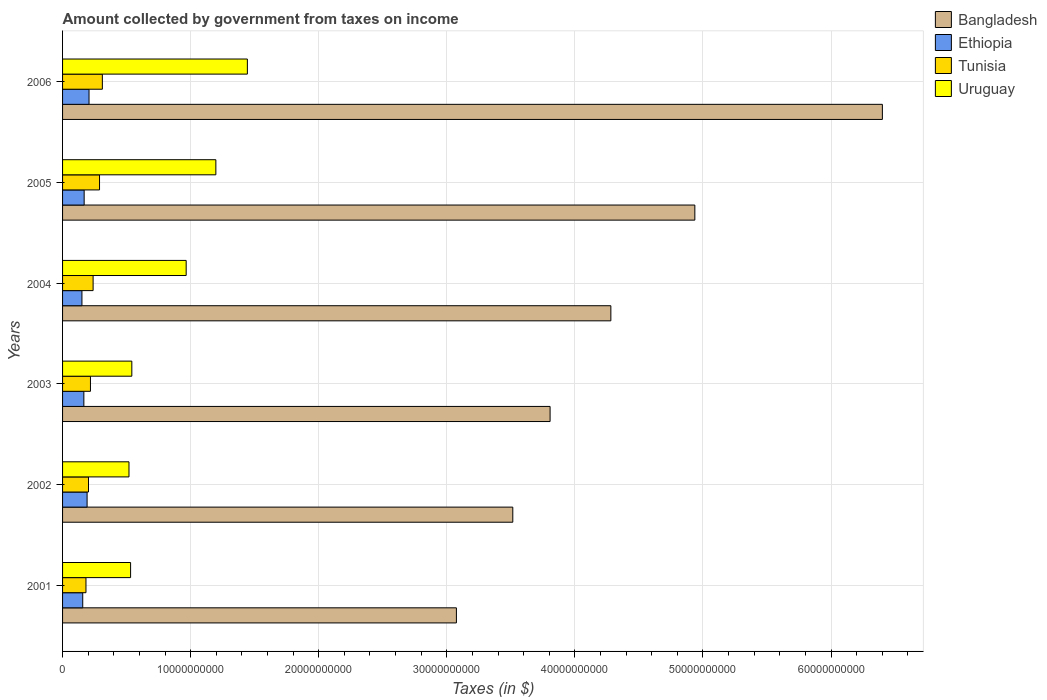How many different coloured bars are there?
Your answer should be compact. 4. Are the number of bars on each tick of the Y-axis equal?
Offer a terse response. Yes. What is the label of the 3rd group of bars from the top?
Offer a very short reply. 2004. In how many cases, is the number of bars for a given year not equal to the number of legend labels?
Offer a terse response. 0. What is the amount collected by government from taxes on income in Ethiopia in 2006?
Provide a short and direct response. 2.07e+09. Across all years, what is the maximum amount collected by government from taxes on income in Tunisia?
Provide a succinct answer. 3.11e+09. Across all years, what is the minimum amount collected by government from taxes on income in Tunisia?
Make the answer very short. 1.83e+09. What is the total amount collected by government from taxes on income in Uruguay in the graph?
Keep it short and to the point. 5.20e+1. What is the difference between the amount collected by government from taxes on income in Tunisia in 2002 and that in 2006?
Give a very brief answer. -1.08e+09. What is the difference between the amount collected by government from taxes on income in Uruguay in 2006 and the amount collected by government from taxes on income in Tunisia in 2003?
Your response must be concise. 1.23e+1. What is the average amount collected by government from taxes on income in Tunisia per year?
Provide a short and direct response. 2.40e+09. In the year 2001, what is the difference between the amount collected by government from taxes on income in Bangladesh and amount collected by government from taxes on income in Ethiopia?
Your response must be concise. 2.92e+1. In how many years, is the amount collected by government from taxes on income in Uruguay greater than 20000000000 $?
Provide a succinct answer. 0. What is the ratio of the amount collected by government from taxes on income in Tunisia in 2002 to that in 2005?
Provide a succinct answer. 0.7. Is the difference between the amount collected by government from taxes on income in Bangladesh in 2004 and 2005 greater than the difference between the amount collected by government from taxes on income in Ethiopia in 2004 and 2005?
Make the answer very short. No. What is the difference between the highest and the second highest amount collected by government from taxes on income in Tunisia?
Your answer should be very brief. 2.20e+08. What is the difference between the highest and the lowest amount collected by government from taxes on income in Uruguay?
Keep it short and to the point. 9.24e+09. What does the 1st bar from the top in 2003 represents?
Your answer should be compact. Uruguay. What does the 2nd bar from the bottom in 2001 represents?
Provide a succinct answer. Ethiopia. Is it the case that in every year, the sum of the amount collected by government from taxes on income in Bangladesh and amount collected by government from taxes on income in Ethiopia is greater than the amount collected by government from taxes on income in Tunisia?
Provide a succinct answer. Yes. Are the values on the major ticks of X-axis written in scientific E-notation?
Provide a short and direct response. No. Does the graph contain grids?
Your response must be concise. Yes. Where does the legend appear in the graph?
Keep it short and to the point. Top right. What is the title of the graph?
Provide a succinct answer. Amount collected by government from taxes on income. What is the label or title of the X-axis?
Provide a succinct answer. Taxes (in $). What is the label or title of the Y-axis?
Offer a terse response. Years. What is the Taxes (in $) in Bangladesh in 2001?
Offer a very short reply. 3.07e+1. What is the Taxes (in $) in Ethiopia in 2001?
Offer a terse response. 1.57e+09. What is the Taxes (in $) in Tunisia in 2001?
Offer a very short reply. 1.83e+09. What is the Taxes (in $) of Uruguay in 2001?
Provide a succinct answer. 5.31e+09. What is the Taxes (in $) of Bangladesh in 2002?
Give a very brief answer. 3.52e+1. What is the Taxes (in $) in Ethiopia in 2002?
Keep it short and to the point. 1.91e+09. What is the Taxes (in $) in Tunisia in 2002?
Your answer should be very brief. 2.02e+09. What is the Taxes (in $) of Uruguay in 2002?
Provide a succinct answer. 5.19e+09. What is the Taxes (in $) in Bangladesh in 2003?
Ensure brevity in your answer.  3.81e+1. What is the Taxes (in $) in Ethiopia in 2003?
Keep it short and to the point. 1.66e+09. What is the Taxes (in $) of Tunisia in 2003?
Provide a short and direct response. 2.18e+09. What is the Taxes (in $) in Uruguay in 2003?
Provide a short and direct response. 5.41e+09. What is the Taxes (in $) of Bangladesh in 2004?
Your answer should be compact. 4.28e+1. What is the Taxes (in $) of Ethiopia in 2004?
Your response must be concise. 1.51e+09. What is the Taxes (in $) in Tunisia in 2004?
Your response must be concise. 2.39e+09. What is the Taxes (in $) in Uruguay in 2004?
Give a very brief answer. 9.65e+09. What is the Taxes (in $) of Bangladesh in 2005?
Your response must be concise. 4.94e+1. What is the Taxes (in $) of Ethiopia in 2005?
Offer a terse response. 1.69e+09. What is the Taxes (in $) of Tunisia in 2005?
Provide a succinct answer. 2.89e+09. What is the Taxes (in $) of Uruguay in 2005?
Your response must be concise. 1.20e+1. What is the Taxes (in $) of Bangladesh in 2006?
Ensure brevity in your answer.  6.40e+1. What is the Taxes (in $) in Ethiopia in 2006?
Ensure brevity in your answer.  2.07e+09. What is the Taxes (in $) in Tunisia in 2006?
Your answer should be compact. 3.11e+09. What is the Taxes (in $) of Uruguay in 2006?
Your response must be concise. 1.44e+1. Across all years, what is the maximum Taxes (in $) in Bangladesh?
Keep it short and to the point. 6.40e+1. Across all years, what is the maximum Taxes (in $) in Ethiopia?
Make the answer very short. 2.07e+09. Across all years, what is the maximum Taxes (in $) in Tunisia?
Keep it short and to the point. 3.11e+09. Across all years, what is the maximum Taxes (in $) in Uruguay?
Offer a very short reply. 1.44e+1. Across all years, what is the minimum Taxes (in $) of Bangladesh?
Provide a short and direct response. 3.07e+1. Across all years, what is the minimum Taxes (in $) in Ethiopia?
Make the answer very short. 1.51e+09. Across all years, what is the minimum Taxes (in $) in Tunisia?
Offer a terse response. 1.83e+09. Across all years, what is the minimum Taxes (in $) of Uruguay?
Your answer should be compact. 5.19e+09. What is the total Taxes (in $) of Bangladesh in the graph?
Make the answer very short. 2.60e+11. What is the total Taxes (in $) in Ethiopia in the graph?
Make the answer very short. 1.04e+1. What is the total Taxes (in $) of Tunisia in the graph?
Your answer should be very brief. 1.44e+1. What is the total Taxes (in $) of Uruguay in the graph?
Make the answer very short. 5.20e+1. What is the difference between the Taxes (in $) of Bangladesh in 2001 and that in 2002?
Your answer should be very brief. -4.40e+09. What is the difference between the Taxes (in $) of Ethiopia in 2001 and that in 2002?
Your response must be concise. -3.40e+08. What is the difference between the Taxes (in $) in Tunisia in 2001 and that in 2002?
Your answer should be very brief. -1.97e+08. What is the difference between the Taxes (in $) of Uruguay in 2001 and that in 2002?
Offer a very short reply. 1.25e+08. What is the difference between the Taxes (in $) of Bangladesh in 2001 and that in 2003?
Provide a succinct answer. -7.31e+09. What is the difference between the Taxes (in $) of Ethiopia in 2001 and that in 2003?
Offer a very short reply. -8.84e+07. What is the difference between the Taxes (in $) of Tunisia in 2001 and that in 2003?
Give a very brief answer. -3.49e+08. What is the difference between the Taxes (in $) in Uruguay in 2001 and that in 2003?
Your answer should be very brief. -9.64e+07. What is the difference between the Taxes (in $) in Bangladesh in 2001 and that in 2004?
Offer a terse response. -1.21e+1. What is the difference between the Taxes (in $) of Ethiopia in 2001 and that in 2004?
Provide a succinct answer. 6.19e+07. What is the difference between the Taxes (in $) in Tunisia in 2001 and that in 2004?
Make the answer very short. -5.58e+08. What is the difference between the Taxes (in $) of Uruguay in 2001 and that in 2004?
Your answer should be compact. -4.34e+09. What is the difference between the Taxes (in $) in Bangladesh in 2001 and that in 2005?
Provide a short and direct response. -1.86e+1. What is the difference between the Taxes (in $) in Ethiopia in 2001 and that in 2005?
Ensure brevity in your answer.  -1.11e+08. What is the difference between the Taxes (in $) in Tunisia in 2001 and that in 2005?
Ensure brevity in your answer.  -1.06e+09. What is the difference between the Taxes (in $) in Uruguay in 2001 and that in 2005?
Your answer should be compact. -6.66e+09. What is the difference between the Taxes (in $) in Bangladesh in 2001 and that in 2006?
Ensure brevity in your answer.  -3.33e+1. What is the difference between the Taxes (in $) in Ethiopia in 2001 and that in 2006?
Offer a terse response. -4.92e+08. What is the difference between the Taxes (in $) in Tunisia in 2001 and that in 2006?
Make the answer very short. -1.28e+09. What is the difference between the Taxes (in $) in Uruguay in 2001 and that in 2006?
Offer a very short reply. -9.12e+09. What is the difference between the Taxes (in $) of Bangladesh in 2002 and that in 2003?
Provide a short and direct response. -2.91e+09. What is the difference between the Taxes (in $) in Ethiopia in 2002 and that in 2003?
Your answer should be compact. 2.52e+08. What is the difference between the Taxes (in $) of Tunisia in 2002 and that in 2003?
Make the answer very short. -1.53e+08. What is the difference between the Taxes (in $) in Uruguay in 2002 and that in 2003?
Give a very brief answer. -2.22e+08. What is the difference between the Taxes (in $) of Bangladesh in 2002 and that in 2004?
Provide a short and direct response. -7.66e+09. What is the difference between the Taxes (in $) in Ethiopia in 2002 and that in 2004?
Offer a terse response. 4.02e+08. What is the difference between the Taxes (in $) in Tunisia in 2002 and that in 2004?
Give a very brief answer. -3.61e+08. What is the difference between the Taxes (in $) of Uruguay in 2002 and that in 2004?
Provide a short and direct response. -4.46e+09. What is the difference between the Taxes (in $) of Bangladesh in 2002 and that in 2005?
Your answer should be very brief. -1.42e+1. What is the difference between the Taxes (in $) in Ethiopia in 2002 and that in 2005?
Your answer should be very brief. 2.29e+08. What is the difference between the Taxes (in $) in Tunisia in 2002 and that in 2005?
Offer a very short reply. -8.62e+08. What is the difference between the Taxes (in $) of Uruguay in 2002 and that in 2005?
Your answer should be compact. -6.78e+09. What is the difference between the Taxes (in $) of Bangladesh in 2002 and that in 2006?
Your response must be concise. -2.89e+1. What is the difference between the Taxes (in $) in Ethiopia in 2002 and that in 2006?
Give a very brief answer. -1.51e+08. What is the difference between the Taxes (in $) in Tunisia in 2002 and that in 2006?
Provide a succinct answer. -1.08e+09. What is the difference between the Taxes (in $) in Uruguay in 2002 and that in 2006?
Give a very brief answer. -9.24e+09. What is the difference between the Taxes (in $) of Bangladesh in 2003 and that in 2004?
Your response must be concise. -4.74e+09. What is the difference between the Taxes (in $) in Ethiopia in 2003 and that in 2004?
Provide a succinct answer. 1.50e+08. What is the difference between the Taxes (in $) of Tunisia in 2003 and that in 2004?
Keep it short and to the point. -2.08e+08. What is the difference between the Taxes (in $) of Uruguay in 2003 and that in 2004?
Offer a terse response. -4.24e+09. What is the difference between the Taxes (in $) in Bangladesh in 2003 and that in 2005?
Offer a terse response. -1.13e+1. What is the difference between the Taxes (in $) of Ethiopia in 2003 and that in 2005?
Your response must be concise. -2.28e+07. What is the difference between the Taxes (in $) of Tunisia in 2003 and that in 2005?
Offer a terse response. -7.09e+08. What is the difference between the Taxes (in $) in Uruguay in 2003 and that in 2005?
Make the answer very short. -6.56e+09. What is the difference between the Taxes (in $) of Bangladesh in 2003 and that in 2006?
Ensure brevity in your answer.  -2.59e+1. What is the difference between the Taxes (in $) in Ethiopia in 2003 and that in 2006?
Your answer should be very brief. -4.03e+08. What is the difference between the Taxes (in $) of Tunisia in 2003 and that in 2006?
Keep it short and to the point. -9.30e+08. What is the difference between the Taxes (in $) of Uruguay in 2003 and that in 2006?
Offer a very short reply. -9.02e+09. What is the difference between the Taxes (in $) of Bangladesh in 2004 and that in 2005?
Your answer should be compact. -6.56e+09. What is the difference between the Taxes (in $) in Ethiopia in 2004 and that in 2005?
Your answer should be compact. -1.73e+08. What is the difference between the Taxes (in $) of Tunisia in 2004 and that in 2005?
Give a very brief answer. -5.01e+08. What is the difference between the Taxes (in $) in Uruguay in 2004 and that in 2005?
Provide a succinct answer. -2.32e+09. What is the difference between the Taxes (in $) of Bangladesh in 2004 and that in 2006?
Give a very brief answer. -2.12e+1. What is the difference between the Taxes (in $) in Ethiopia in 2004 and that in 2006?
Give a very brief answer. -5.54e+08. What is the difference between the Taxes (in $) in Tunisia in 2004 and that in 2006?
Give a very brief answer. -7.22e+08. What is the difference between the Taxes (in $) of Uruguay in 2004 and that in 2006?
Ensure brevity in your answer.  -4.78e+09. What is the difference between the Taxes (in $) of Bangladesh in 2005 and that in 2006?
Your answer should be very brief. -1.46e+1. What is the difference between the Taxes (in $) of Ethiopia in 2005 and that in 2006?
Make the answer very short. -3.80e+08. What is the difference between the Taxes (in $) in Tunisia in 2005 and that in 2006?
Ensure brevity in your answer.  -2.20e+08. What is the difference between the Taxes (in $) of Uruguay in 2005 and that in 2006?
Your answer should be very brief. -2.46e+09. What is the difference between the Taxes (in $) of Bangladesh in 2001 and the Taxes (in $) of Ethiopia in 2002?
Your response must be concise. 2.88e+1. What is the difference between the Taxes (in $) in Bangladesh in 2001 and the Taxes (in $) in Tunisia in 2002?
Offer a terse response. 2.87e+1. What is the difference between the Taxes (in $) in Bangladesh in 2001 and the Taxes (in $) in Uruguay in 2002?
Your response must be concise. 2.56e+1. What is the difference between the Taxes (in $) of Ethiopia in 2001 and the Taxes (in $) of Tunisia in 2002?
Your answer should be compact. -4.50e+08. What is the difference between the Taxes (in $) of Ethiopia in 2001 and the Taxes (in $) of Uruguay in 2002?
Provide a succinct answer. -3.61e+09. What is the difference between the Taxes (in $) in Tunisia in 2001 and the Taxes (in $) in Uruguay in 2002?
Keep it short and to the point. -3.36e+09. What is the difference between the Taxes (in $) of Bangladesh in 2001 and the Taxes (in $) of Ethiopia in 2003?
Your response must be concise. 2.91e+1. What is the difference between the Taxes (in $) of Bangladesh in 2001 and the Taxes (in $) of Tunisia in 2003?
Keep it short and to the point. 2.86e+1. What is the difference between the Taxes (in $) of Bangladesh in 2001 and the Taxes (in $) of Uruguay in 2003?
Your answer should be compact. 2.53e+1. What is the difference between the Taxes (in $) in Ethiopia in 2001 and the Taxes (in $) in Tunisia in 2003?
Provide a short and direct response. -6.02e+08. What is the difference between the Taxes (in $) in Ethiopia in 2001 and the Taxes (in $) in Uruguay in 2003?
Offer a very short reply. -3.83e+09. What is the difference between the Taxes (in $) of Tunisia in 2001 and the Taxes (in $) of Uruguay in 2003?
Provide a short and direct response. -3.58e+09. What is the difference between the Taxes (in $) in Bangladesh in 2001 and the Taxes (in $) in Ethiopia in 2004?
Provide a succinct answer. 2.92e+1. What is the difference between the Taxes (in $) of Bangladesh in 2001 and the Taxes (in $) of Tunisia in 2004?
Give a very brief answer. 2.84e+1. What is the difference between the Taxes (in $) of Bangladesh in 2001 and the Taxes (in $) of Uruguay in 2004?
Offer a very short reply. 2.11e+1. What is the difference between the Taxes (in $) of Ethiopia in 2001 and the Taxes (in $) of Tunisia in 2004?
Make the answer very short. -8.11e+08. What is the difference between the Taxes (in $) of Ethiopia in 2001 and the Taxes (in $) of Uruguay in 2004?
Provide a succinct answer. -8.08e+09. What is the difference between the Taxes (in $) of Tunisia in 2001 and the Taxes (in $) of Uruguay in 2004?
Keep it short and to the point. -7.82e+09. What is the difference between the Taxes (in $) in Bangladesh in 2001 and the Taxes (in $) in Ethiopia in 2005?
Provide a short and direct response. 2.91e+1. What is the difference between the Taxes (in $) in Bangladesh in 2001 and the Taxes (in $) in Tunisia in 2005?
Your answer should be very brief. 2.79e+1. What is the difference between the Taxes (in $) in Bangladesh in 2001 and the Taxes (in $) in Uruguay in 2005?
Provide a short and direct response. 1.88e+1. What is the difference between the Taxes (in $) of Ethiopia in 2001 and the Taxes (in $) of Tunisia in 2005?
Your answer should be very brief. -1.31e+09. What is the difference between the Taxes (in $) of Ethiopia in 2001 and the Taxes (in $) of Uruguay in 2005?
Keep it short and to the point. -1.04e+1. What is the difference between the Taxes (in $) in Tunisia in 2001 and the Taxes (in $) in Uruguay in 2005?
Provide a short and direct response. -1.01e+1. What is the difference between the Taxes (in $) in Bangladesh in 2001 and the Taxes (in $) in Ethiopia in 2006?
Your answer should be very brief. 2.87e+1. What is the difference between the Taxes (in $) of Bangladesh in 2001 and the Taxes (in $) of Tunisia in 2006?
Ensure brevity in your answer.  2.76e+1. What is the difference between the Taxes (in $) in Bangladesh in 2001 and the Taxes (in $) in Uruguay in 2006?
Provide a succinct answer. 1.63e+1. What is the difference between the Taxes (in $) in Ethiopia in 2001 and the Taxes (in $) in Tunisia in 2006?
Keep it short and to the point. -1.53e+09. What is the difference between the Taxes (in $) of Ethiopia in 2001 and the Taxes (in $) of Uruguay in 2006?
Your response must be concise. -1.29e+1. What is the difference between the Taxes (in $) in Tunisia in 2001 and the Taxes (in $) in Uruguay in 2006?
Make the answer very short. -1.26e+1. What is the difference between the Taxes (in $) in Bangladesh in 2002 and the Taxes (in $) in Ethiopia in 2003?
Provide a short and direct response. 3.35e+1. What is the difference between the Taxes (in $) of Bangladesh in 2002 and the Taxes (in $) of Tunisia in 2003?
Ensure brevity in your answer.  3.30e+1. What is the difference between the Taxes (in $) in Bangladesh in 2002 and the Taxes (in $) in Uruguay in 2003?
Keep it short and to the point. 2.97e+1. What is the difference between the Taxes (in $) of Ethiopia in 2002 and the Taxes (in $) of Tunisia in 2003?
Make the answer very short. -2.62e+08. What is the difference between the Taxes (in $) of Ethiopia in 2002 and the Taxes (in $) of Uruguay in 2003?
Your answer should be very brief. -3.49e+09. What is the difference between the Taxes (in $) in Tunisia in 2002 and the Taxes (in $) in Uruguay in 2003?
Offer a very short reply. -3.38e+09. What is the difference between the Taxes (in $) of Bangladesh in 2002 and the Taxes (in $) of Ethiopia in 2004?
Provide a succinct answer. 3.36e+1. What is the difference between the Taxes (in $) of Bangladesh in 2002 and the Taxes (in $) of Tunisia in 2004?
Your answer should be very brief. 3.28e+1. What is the difference between the Taxes (in $) in Bangladesh in 2002 and the Taxes (in $) in Uruguay in 2004?
Ensure brevity in your answer.  2.55e+1. What is the difference between the Taxes (in $) in Ethiopia in 2002 and the Taxes (in $) in Tunisia in 2004?
Ensure brevity in your answer.  -4.71e+08. What is the difference between the Taxes (in $) in Ethiopia in 2002 and the Taxes (in $) in Uruguay in 2004?
Keep it short and to the point. -7.74e+09. What is the difference between the Taxes (in $) of Tunisia in 2002 and the Taxes (in $) of Uruguay in 2004?
Your answer should be compact. -7.63e+09. What is the difference between the Taxes (in $) in Bangladesh in 2002 and the Taxes (in $) in Ethiopia in 2005?
Ensure brevity in your answer.  3.35e+1. What is the difference between the Taxes (in $) of Bangladesh in 2002 and the Taxes (in $) of Tunisia in 2005?
Your answer should be very brief. 3.23e+1. What is the difference between the Taxes (in $) in Bangladesh in 2002 and the Taxes (in $) in Uruguay in 2005?
Offer a terse response. 2.32e+1. What is the difference between the Taxes (in $) of Ethiopia in 2002 and the Taxes (in $) of Tunisia in 2005?
Your response must be concise. -9.72e+08. What is the difference between the Taxes (in $) of Ethiopia in 2002 and the Taxes (in $) of Uruguay in 2005?
Provide a succinct answer. -1.01e+1. What is the difference between the Taxes (in $) in Tunisia in 2002 and the Taxes (in $) in Uruguay in 2005?
Offer a very short reply. -9.94e+09. What is the difference between the Taxes (in $) of Bangladesh in 2002 and the Taxes (in $) of Ethiopia in 2006?
Make the answer very short. 3.31e+1. What is the difference between the Taxes (in $) in Bangladesh in 2002 and the Taxes (in $) in Tunisia in 2006?
Ensure brevity in your answer.  3.20e+1. What is the difference between the Taxes (in $) in Bangladesh in 2002 and the Taxes (in $) in Uruguay in 2006?
Your answer should be compact. 2.07e+1. What is the difference between the Taxes (in $) in Ethiopia in 2002 and the Taxes (in $) in Tunisia in 2006?
Offer a terse response. -1.19e+09. What is the difference between the Taxes (in $) of Ethiopia in 2002 and the Taxes (in $) of Uruguay in 2006?
Your answer should be very brief. -1.25e+1. What is the difference between the Taxes (in $) in Tunisia in 2002 and the Taxes (in $) in Uruguay in 2006?
Give a very brief answer. -1.24e+1. What is the difference between the Taxes (in $) in Bangladesh in 2003 and the Taxes (in $) in Ethiopia in 2004?
Make the answer very short. 3.66e+1. What is the difference between the Taxes (in $) in Bangladesh in 2003 and the Taxes (in $) in Tunisia in 2004?
Keep it short and to the point. 3.57e+1. What is the difference between the Taxes (in $) of Bangladesh in 2003 and the Taxes (in $) of Uruguay in 2004?
Your answer should be compact. 2.84e+1. What is the difference between the Taxes (in $) in Ethiopia in 2003 and the Taxes (in $) in Tunisia in 2004?
Make the answer very short. -7.22e+08. What is the difference between the Taxes (in $) in Ethiopia in 2003 and the Taxes (in $) in Uruguay in 2004?
Provide a short and direct response. -7.99e+09. What is the difference between the Taxes (in $) of Tunisia in 2003 and the Taxes (in $) of Uruguay in 2004?
Provide a short and direct response. -7.47e+09. What is the difference between the Taxes (in $) of Bangladesh in 2003 and the Taxes (in $) of Ethiopia in 2005?
Give a very brief answer. 3.64e+1. What is the difference between the Taxes (in $) of Bangladesh in 2003 and the Taxes (in $) of Tunisia in 2005?
Your answer should be compact. 3.52e+1. What is the difference between the Taxes (in $) in Bangladesh in 2003 and the Taxes (in $) in Uruguay in 2005?
Give a very brief answer. 2.61e+1. What is the difference between the Taxes (in $) in Ethiopia in 2003 and the Taxes (in $) in Tunisia in 2005?
Provide a short and direct response. -1.22e+09. What is the difference between the Taxes (in $) of Ethiopia in 2003 and the Taxes (in $) of Uruguay in 2005?
Your response must be concise. -1.03e+1. What is the difference between the Taxes (in $) of Tunisia in 2003 and the Taxes (in $) of Uruguay in 2005?
Provide a short and direct response. -9.79e+09. What is the difference between the Taxes (in $) of Bangladesh in 2003 and the Taxes (in $) of Ethiopia in 2006?
Your response must be concise. 3.60e+1. What is the difference between the Taxes (in $) in Bangladesh in 2003 and the Taxes (in $) in Tunisia in 2006?
Offer a terse response. 3.50e+1. What is the difference between the Taxes (in $) in Bangladesh in 2003 and the Taxes (in $) in Uruguay in 2006?
Your answer should be compact. 2.36e+1. What is the difference between the Taxes (in $) in Ethiopia in 2003 and the Taxes (in $) in Tunisia in 2006?
Provide a succinct answer. -1.44e+09. What is the difference between the Taxes (in $) in Ethiopia in 2003 and the Taxes (in $) in Uruguay in 2006?
Ensure brevity in your answer.  -1.28e+1. What is the difference between the Taxes (in $) in Tunisia in 2003 and the Taxes (in $) in Uruguay in 2006?
Your answer should be very brief. -1.23e+1. What is the difference between the Taxes (in $) of Bangladesh in 2004 and the Taxes (in $) of Ethiopia in 2005?
Offer a very short reply. 4.11e+1. What is the difference between the Taxes (in $) of Bangladesh in 2004 and the Taxes (in $) of Tunisia in 2005?
Offer a very short reply. 3.99e+1. What is the difference between the Taxes (in $) of Bangladesh in 2004 and the Taxes (in $) of Uruguay in 2005?
Provide a succinct answer. 3.08e+1. What is the difference between the Taxes (in $) of Ethiopia in 2004 and the Taxes (in $) of Tunisia in 2005?
Keep it short and to the point. -1.37e+09. What is the difference between the Taxes (in $) of Ethiopia in 2004 and the Taxes (in $) of Uruguay in 2005?
Offer a very short reply. -1.05e+1. What is the difference between the Taxes (in $) in Tunisia in 2004 and the Taxes (in $) in Uruguay in 2005?
Your response must be concise. -9.58e+09. What is the difference between the Taxes (in $) of Bangladesh in 2004 and the Taxes (in $) of Ethiopia in 2006?
Give a very brief answer. 4.07e+1. What is the difference between the Taxes (in $) in Bangladesh in 2004 and the Taxes (in $) in Tunisia in 2006?
Provide a succinct answer. 3.97e+1. What is the difference between the Taxes (in $) in Bangladesh in 2004 and the Taxes (in $) in Uruguay in 2006?
Your answer should be very brief. 2.84e+1. What is the difference between the Taxes (in $) of Ethiopia in 2004 and the Taxes (in $) of Tunisia in 2006?
Give a very brief answer. -1.59e+09. What is the difference between the Taxes (in $) in Ethiopia in 2004 and the Taxes (in $) in Uruguay in 2006?
Keep it short and to the point. -1.29e+1. What is the difference between the Taxes (in $) in Tunisia in 2004 and the Taxes (in $) in Uruguay in 2006?
Your answer should be compact. -1.20e+1. What is the difference between the Taxes (in $) of Bangladesh in 2005 and the Taxes (in $) of Ethiopia in 2006?
Offer a terse response. 4.73e+1. What is the difference between the Taxes (in $) of Bangladesh in 2005 and the Taxes (in $) of Tunisia in 2006?
Ensure brevity in your answer.  4.63e+1. What is the difference between the Taxes (in $) of Bangladesh in 2005 and the Taxes (in $) of Uruguay in 2006?
Offer a very short reply. 3.49e+1. What is the difference between the Taxes (in $) of Ethiopia in 2005 and the Taxes (in $) of Tunisia in 2006?
Offer a very short reply. -1.42e+09. What is the difference between the Taxes (in $) in Ethiopia in 2005 and the Taxes (in $) in Uruguay in 2006?
Make the answer very short. -1.27e+1. What is the difference between the Taxes (in $) in Tunisia in 2005 and the Taxes (in $) in Uruguay in 2006?
Provide a succinct answer. -1.15e+1. What is the average Taxes (in $) of Bangladesh per year?
Offer a terse response. 4.34e+1. What is the average Taxes (in $) in Ethiopia per year?
Give a very brief answer. 1.74e+09. What is the average Taxes (in $) in Tunisia per year?
Offer a very short reply. 2.40e+09. What is the average Taxes (in $) in Uruguay per year?
Offer a terse response. 8.66e+09. In the year 2001, what is the difference between the Taxes (in $) of Bangladesh and Taxes (in $) of Ethiopia?
Offer a terse response. 2.92e+1. In the year 2001, what is the difference between the Taxes (in $) in Bangladesh and Taxes (in $) in Tunisia?
Your response must be concise. 2.89e+1. In the year 2001, what is the difference between the Taxes (in $) of Bangladesh and Taxes (in $) of Uruguay?
Offer a terse response. 2.54e+1. In the year 2001, what is the difference between the Taxes (in $) in Ethiopia and Taxes (in $) in Tunisia?
Keep it short and to the point. -2.53e+08. In the year 2001, what is the difference between the Taxes (in $) in Ethiopia and Taxes (in $) in Uruguay?
Provide a succinct answer. -3.74e+09. In the year 2001, what is the difference between the Taxes (in $) in Tunisia and Taxes (in $) in Uruguay?
Provide a short and direct response. -3.48e+09. In the year 2002, what is the difference between the Taxes (in $) in Bangladesh and Taxes (in $) in Ethiopia?
Provide a succinct answer. 3.32e+1. In the year 2002, what is the difference between the Taxes (in $) in Bangladesh and Taxes (in $) in Tunisia?
Your response must be concise. 3.31e+1. In the year 2002, what is the difference between the Taxes (in $) in Bangladesh and Taxes (in $) in Uruguay?
Your answer should be very brief. 3.00e+1. In the year 2002, what is the difference between the Taxes (in $) of Ethiopia and Taxes (in $) of Tunisia?
Your answer should be very brief. -1.10e+08. In the year 2002, what is the difference between the Taxes (in $) in Ethiopia and Taxes (in $) in Uruguay?
Your answer should be compact. -3.27e+09. In the year 2002, what is the difference between the Taxes (in $) in Tunisia and Taxes (in $) in Uruguay?
Keep it short and to the point. -3.16e+09. In the year 2003, what is the difference between the Taxes (in $) of Bangladesh and Taxes (in $) of Ethiopia?
Your answer should be compact. 3.64e+1. In the year 2003, what is the difference between the Taxes (in $) in Bangladesh and Taxes (in $) in Tunisia?
Make the answer very short. 3.59e+1. In the year 2003, what is the difference between the Taxes (in $) of Bangladesh and Taxes (in $) of Uruguay?
Your answer should be very brief. 3.27e+1. In the year 2003, what is the difference between the Taxes (in $) in Ethiopia and Taxes (in $) in Tunisia?
Your answer should be compact. -5.14e+08. In the year 2003, what is the difference between the Taxes (in $) in Ethiopia and Taxes (in $) in Uruguay?
Give a very brief answer. -3.74e+09. In the year 2003, what is the difference between the Taxes (in $) of Tunisia and Taxes (in $) of Uruguay?
Offer a very short reply. -3.23e+09. In the year 2004, what is the difference between the Taxes (in $) of Bangladesh and Taxes (in $) of Ethiopia?
Offer a very short reply. 4.13e+1. In the year 2004, what is the difference between the Taxes (in $) in Bangladesh and Taxes (in $) in Tunisia?
Your answer should be compact. 4.04e+1. In the year 2004, what is the difference between the Taxes (in $) in Bangladesh and Taxes (in $) in Uruguay?
Keep it short and to the point. 3.32e+1. In the year 2004, what is the difference between the Taxes (in $) of Ethiopia and Taxes (in $) of Tunisia?
Your answer should be very brief. -8.73e+08. In the year 2004, what is the difference between the Taxes (in $) in Ethiopia and Taxes (in $) in Uruguay?
Give a very brief answer. -8.14e+09. In the year 2004, what is the difference between the Taxes (in $) of Tunisia and Taxes (in $) of Uruguay?
Provide a succinct answer. -7.27e+09. In the year 2005, what is the difference between the Taxes (in $) in Bangladesh and Taxes (in $) in Ethiopia?
Keep it short and to the point. 4.77e+1. In the year 2005, what is the difference between the Taxes (in $) of Bangladesh and Taxes (in $) of Tunisia?
Ensure brevity in your answer.  4.65e+1. In the year 2005, what is the difference between the Taxes (in $) of Bangladesh and Taxes (in $) of Uruguay?
Your response must be concise. 3.74e+1. In the year 2005, what is the difference between the Taxes (in $) of Ethiopia and Taxes (in $) of Tunisia?
Your response must be concise. -1.20e+09. In the year 2005, what is the difference between the Taxes (in $) of Ethiopia and Taxes (in $) of Uruguay?
Your response must be concise. -1.03e+1. In the year 2005, what is the difference between the Taxes (in $) of Tunisia and Taxes (in $) of Uruguay?
Keep it short and to the point. -9.08e+09. In the year 2006, what is the difference between the Taxes (in $) of Bangladesh and Taxes (in $) of Ethiopia?
Your response must be concise. 6.19e+1. In the year 2006, what is the difference between the Taxes (in $) of Bangladesh and Taxes (in $) of Tunisia?
Offer a very short reply. 6.09e+1. In the year 2006, what is the difference between the Taxes (in $) in Bangladesh and Taxes (in $) in Uruguay?
Ensure brevity in your answer.  4.96e+1. In the year 2006, what is the difference between the Taxes (in $) in Ethiopia and Taxes (in $) in Tunisia?
Provide a short and direct response. -1.04e+09. In the year 2006, what is the difference between the Taxes (in $) of Ethiopia and Taxes (in $) of Uruguay?
Give a very brief answer. -1.24e+1. In the year 2006, what is the difference between the Taxes (in $) in Tunisia and Taxes (in $) in Uruguay?
Offer a very short reply. -1.13e+1. What is the ratio of the Taxes (in $) of Bangladesh in 2001 to that in 2002?
Keep it short and to the point. 0.87. What is the ratio of the Taxes (in $) of Ethiopia in 2001 to that in 2002?
Offer a terse response. 0.82. What is the ratio of the Taxes (in $) of Tunisia in 2001 to that in 2002?
Provide a succinct answer. 0.9. What is the ratio of the Taxes (in $) of Uruguay in 2001 to that in 2002?
Offer a terse response. 1.02. What is the ratio of the Taxes (in $) of Bangladesh in 2001 to that in 2003?
Provide a short and direct response. 0.81. What is the ratio of the Taxes (in $) of Ethiopia in 2001 to that in 2003?
Provide a succinct answer. 0.95. What is the ratio of the Taxes (in $) in Tunisia in 2001 to that in 2003?
Your answer should be very brief. 0.84. What is the ratio of the Taxes (in $) in Uruguay in 2001 to that in 2003?
Your answer should be compact. 0.98. What is the ratio of the Taxes (in $) in Bangladesh in 2001 to that in 2004?
Provide a short and direct response. 0.72. What is the ratio of the Taxes (in $) in Ethiopia in 2001 to that in 2004?
Give a very brief answer. 1.04. What is the ratio of the Taxes (in $) of Tunisia in 2001 to that in 2004?
Keep it short and to the point. 0.77. What is the ratio of the Taxes (in $) in Uruguay in 2001 to that in 2004?
Keep it short and to the point. 0.55. What is the ratio of the Taxes (in $) of Bangladesh in 2001 to that in 2005?
Give a very brief answer. 0.62. What is the ratio of the Taxes (in $) in Ethiopia in 2001 to that in 2005?
Your response must be concise. 0.93. What is the ratio of the Taxes (in $) of Tunisia in 2001 to that in 2005?
Offer a very short reply. 0.63. What is the ratio of the Taxes (in $) of Uruguay in 2001 to that in 2005?
Your answer should be very brief. 0.44. What is the ratio of the Taxes (in $) in Bangladesh in 2001 to that in 2006?
Provide a short and direct response. 0.48. What is the ratio of the Taxes (in $) of Ethiopia in 2001 to that in 2006?
Make the answer very short. 0.76. What is the ratio of the Taxes (in $) in Tunisia in 2001 to that in 2006?
Provide a succinct answer. 0.59. What is the ratio of the Taxes (in $) of Uruguay in 2001 to that in 2006?
Your answer should be very brief. 0.37. What is the ratio of the Taxes (in $) in Bangladesh in 2002 to that in 2003?
Provide a short and direct response. 0.92. What is the ratio of the Taxes (in $) of Ethiopia in 2002 to that in 2003?
Give a very brief answer. 1.15. What is the ratio of the Taxes (in $) of Tunisia in 2002 to that in 2003?
Your answer should be compact. 0.93. What is the ratio of the Taxes (in $) in Bangladesh in 2002 to that in 2004?
Provide a short and direct response. 0.82. What is the ratio of the Taxes (in $) in Ethiopia in 2002 to that in 2004?
Keep it short and to the point. 1.27. What is the ratio of the Taxes (in $) in Tunisia in 2002 to that in 2004?
Offer a very short reply. 0.85. What is the ratio of the Taxes (in $) in Uruguay in 2002 to that in 2004?
Your answer should be compact. 0.54. What is the ratio of the Taxes (in $) of Bangladesh in 2002 to that in 2005?
Provide a short and direct response. 0.71. What is the ratio of the Taxes (in $) in Ethiopia in 2002 to that in 2005?
Offer a terse response. 1.14. What is the ratio of the Taxes (in $) of Tunisia in 2002 to that in 2005?
Your answer should be very brief. 0.7. What is the ratio of the Taxes (in $) in Uruguay in 2002 to that in 2005?
Your response must be concise. 0.43. What is the ratio of the Taxes (in $) of Bangladesh in 2002 to that in 2006?
Your response must be concise. 0.55. What is the ratio of the Taxes (in $) in Ethiopia in 2002 to that in 2006?
Ensure brevity in your answer.  0.93. What is the ratio of the Taxes (in $) of Tunisia in 2002 to that in 2006?
Ensure brevity in your answer.  0.65. What is the ratio of the Taxes (in $) in Uruguay in 2002 to that in 2006?
Provide a succinct answer. 0.36. What is the ratio of the Taxes (in $) in Bangladesh in 2003 to that in 2004?
Offer a terse response. 0.89. What is the ratio of the Taxes (in $) of Ethiopia in 2003 to that in 2004?
Your response must be concise. 1.1. What is the ratio of the Taxes (in $) in Tunisia in 2003 to that in 2004?
Give a very brief answer. 0.91. What is the ratio of the Taxes (in $) of Uruguay in 2003 to that in 2004?
Ensure brevity in your answer.  0.56. What is the ratio of the Taxes (in $) of Bangladesh in 2003 to that in 2005?
Ensure brevity in your answer.  0.77. What is the ratio of the Taxes (in $) in Ethiopia in 2003 to that in 2005?
Ensure brevity in your answer.  0.99. What is the ratio of the Taxes (in $) of Tunisia in 2003 to that in 2005?
Offer a very short reply. 0.75. What is the ratio of the Taxes (in $) in Uruguay in 2003 to that in 2005?
Provide a succinct answer. 0.45. What is the ratio of the Taxes (in $) of Bangladesh in 2003 to that in 2006?
Offer a very short reply. 0.59. What is the ratio of the Taxes (in $) of Ethiopia in 2003 to that in 2006?
Provide a short and direct response. 0.8. What is the ratio of the Taxes (in $) of Tunisia in 2003 to that in 2006?
Give a very brief answer. 0.7. What is the ratio of the Taxes (in $) in Uruguay in 2003 to that in 2006?
Offer a very short reply. 0.37. What is the ratio of the Taxes (in $) in Bangladesh in 2004 to that in 2005?
Your answer should be compact. 0.87. What is the ratio of the Taxes (in $) of Ethiopia in 2004 to that in 2005?
Make the answer very short. 0.9. What is the ratio of the Taxes (in $) in Tunisia in 2004 to that in 2005?
Offer a very short reply. 0.83. What is the ratio of the Taxes (in $) of Uruguay in 2004 to that in 2005?
Offer a terse response. 0.81. What is the ratio of the Taxes (in $) in Bangladesh in 2004 to that in 2006?
Offer a very short reply. 0.67. What is the ratio of the Taxes (in $) in Ethiopia in 2004 to that in 2006?
Offer a very short reply. 0.73. What is the ratio of the Taxes (in $) in Tunisia in 2004 to that in 2006?
Make the answer very short. 0.77. What is the ratio of the Taxes (in $) of Uruguay in 2004 to that in 2006?
Offer a terse response. 0.67. What is the ratio of the Taxes (in $) in Bangladesh in 2005 to that in 2006?
Provide a succinct answer. 0.77. What is the ratio of the Taxes (in $) of Ethiopia in 2005 to that in 2006?
Offer a very short reply. 0.82. What is the ratio of the Taxes (in $) in Tunisia in 2005 to that in 2006?
Provide a succinct answer. 0.93. What is the ratio of the Taxes (in $) of Uruguay in 2005 to that in 2006?
Make the answer very short. 0.83. What is the difference between the highest and the second highest Taxes (in $) in Bangladesh?
Your answer should be compact. 1.46e+1. What is the difference between the highest and the second highest Taxes (in $) of Ethiopia?
Offer a very short reply. 1.51e+08. What is the difference between the highest and the second highest Taxes (in $) of Tunisia?
Ensure brevity in your answer.  2.20e+08. What is the difference between the highest and the second highest Taxes (in $) in Uruguay?
Provide a short and direct response. 2.46e+09. What is the difference between the highest and the lowest Taxes (in $) of Bangladesh?
Your answer should be very brief. 3.33e+1. What is the difference between the highest and the lowest Taxes (in $) of Ethiopia?
Make the answer very short. 5.54e+08. What is the difference between the highest and the lowest Taxes (in $) in Tunisia?
Ensure brevity in your answer.  1.28e+09. What is the difference between the highest and the lowest Taxes (in $) of Uruguay?
Provide a short and direct response. 9.24e+09. 